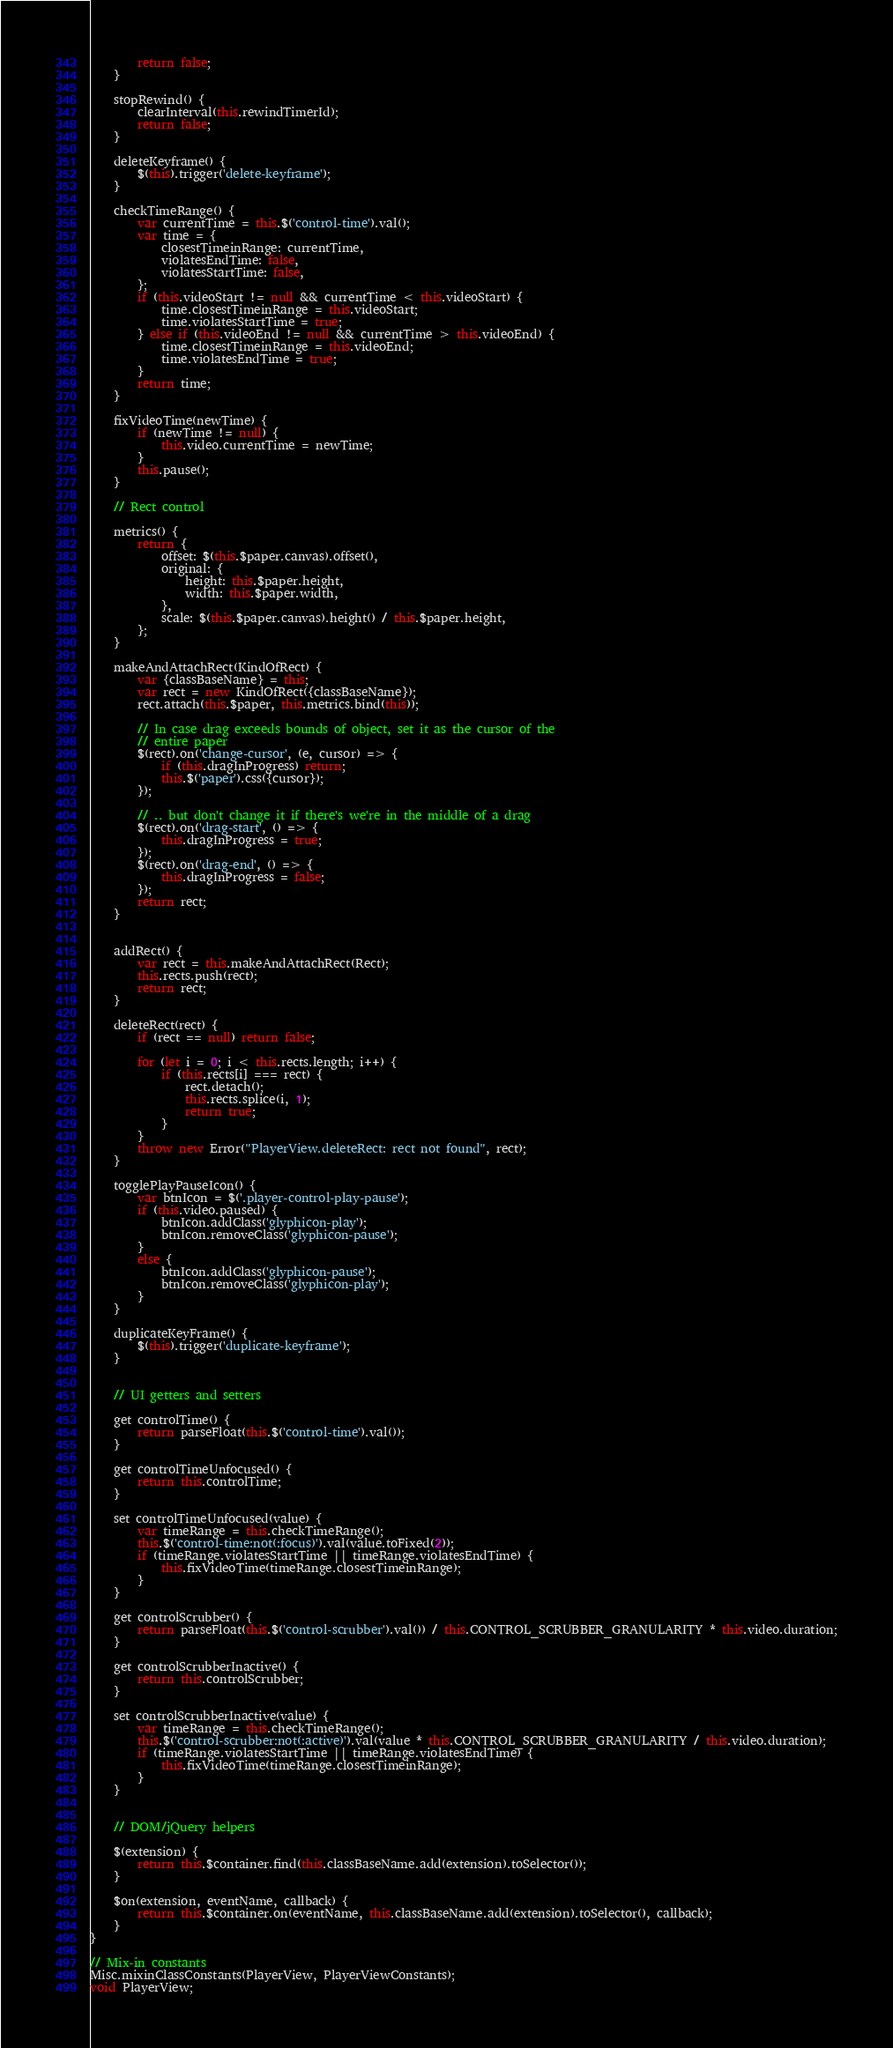<code> <loc_0><loc_0><loc_500><loc_500><_JavaScript_>        return false;
    }

    stopRewind() {
        clearInterval(this.rewindTimerId);
        return false;
    }

    deleteKeyframe() {
        $(this).trigger('delete-keyframe');
    }

    checkTimeRange() {
        var currentTime = this.$('control-time').val();
        var time = {
            closestTimeinRange: currentTime,
            violatesEndTime: false,
            violatesStartTime: false,
        };
        if (this.videoStart != null && currentTime < this.videoStart) {
            time.closestTimeinRange = this.videoStart;
            time.violatesStartTime = true;
        } else if (this.videoEnd != null && currentTime > this.videoEnd) {
            time.closestTimeinRange = this.videoEnd;
            time.violatesEndTime = true;
        }
        return time;
    }

    fixVideoTime(newTime) {
        if (newTime != null) {
            this.video.currentTime = newTime;
        }
        this.pause();
    }

    // Rect control

    metrics() {
        return {
            offset: $(this.$paper.canvas).offset(),
            original: {
                height: this.$paper.height,
                width: this.$paper.width,
            },
            scale: $(this.$paper.canvas).height() / this.$paper.height,
        };
    }

    makeAndAttachRect(KindOfRect) {
        var {classBaseName} = this;
        var rect = new KindOfRect({classBaseName});
        rect.attach(this.$paper, this.metrics.bind(this));

        // In case drag exceeds bounds of object, set it as the cursor of the
        // entire paper
        $(rect).on('change-cursor', (e, cursor) => {
            if (this.dragInProgress) return;
            this.$('paper').css({cursor});
        });

        // .. but don't change it if there's we're in the middle of a drag
        $(rect).on('drag-start', () => {
            this.dragInProgress = true;
        });
        $(rect).on('drag-end', () => {
            this.dragInProgress = false;
        });
        return rect;
    }


    addRect() {
        var rect = this.makeAndAttachRect(Rect);
        this.rects.push(rect);
        return rect;
    }

    deleteRect(rect) {
        if (rect == null) return false;

        for (let i = 0; i < this.rects.length; i++) {
            if (this.rects[i] === rect) {
                rect.detach();
                this.rects.splice(i, 1);
                return true;
            }
        }
        throw new Error("PlayerView.deleteRect: rect not found", rect);
    }

    togglePlayPauseIcon() {
        var btnIcon = $('.player-control-play-pause');
        if (this.video.paused) {
            btnIcon.addClass('glyphicon-play');
            btnIcon.removeClass('glyphicon-pause');
        }
        else {
            btnIcon.addClass('glyphicon-pause');
            btnIcon.removeClass('glyphicon-play');
        }
    }

    duplicateKeyFrame() {
        $(this).trigger('duplicate-keyframe');
    }


    // UI getters and setters

    get controlTime() {
        return parseFloat(this.$('control-time').val());
    }

    get controlTimeUnfocused() {
        return this.controlTime;
    }

    set controlTimeUnfocused(value) {
        var timeRange = this.checkTimeRange();
        this.$('control-time:not(:focus)').val(value.toFixed(2));
        if (timeRange.violatesStartTime || timeRange.violatesEndTime) {
            this.fixVideoTime(timeRange.closestTimeinRange);
        }
    }

    get controlScrubber() {
        return parseFloat(this.$('control-scrubber').val()) / this.CONTROL_SCRUBBER_GRANULARITY * this.video.duration;
    }

    get controlScrubberInactive() {
        return this.controlScrubber;
    }

    set controlScrubberInactive(value) {
        var timeRange = this.checkTimeRange();
        this.$('control-scrubber:not(:active)').val(value * this.CONTROL_SCRUBBER_GRANULARITY / this.video.duration);
        if (timeRange.violatesStartTime || timeRange.violatesEndTime) {
            this.fixVideoTime(timeRange.closestTimeinRange);
        }
    }


    // DOM/jQuery helpers

    $(extension) {
        return this.$container.find(this.classBaseName.add(extension).toSelector());
    }

    $on(extension, eventName, callback) {
        return this.$container.on(eventName, this.classBaseName.add(extension).toSelector(), callback);
    }
}

// Mix-in constants
Misc.mixinClassConstants(PlayerView, PlayerViewConstants);
void PlayerView;
</code> 